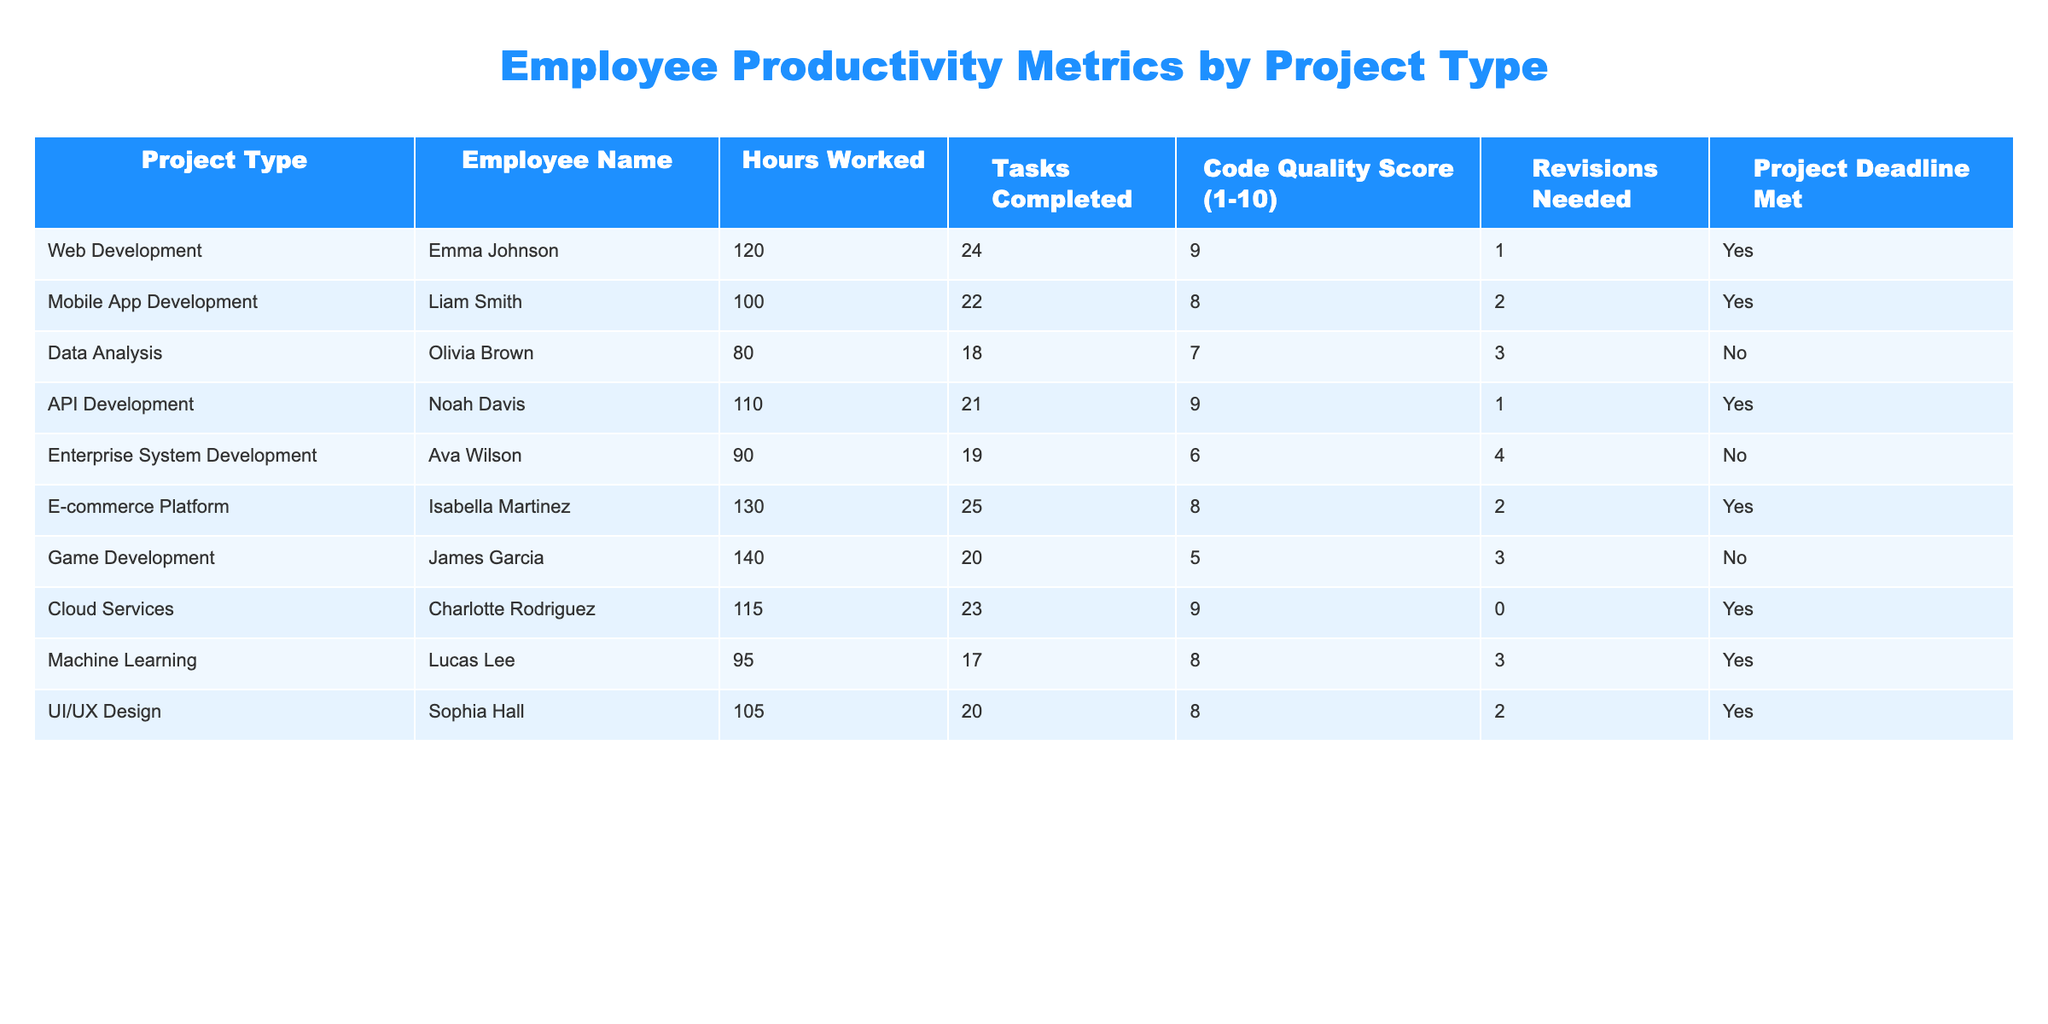What is the highest code quality score among the projects? By reviewing the "Code Quality Score" column, I identify the scores for each project type. The scores are: 9 (Web Development), 8 (Mobile App Development), 7 (Data Analysis), 9 (API Development), 6 (Enterprise System Development), 8 (E-commerce Platform), 5 (Game Development), 9 (Cloud Services), 8 (Machine Learning), and 8 (UI/UX Design). The highest score is 9.
Answer: 9 How many hours did employees work on Mobile App Development? Checking the "Hours Worked" column specifically for the row related to Mobile App Development, I find that Liam Smith worked 100 hours on that project.
Answer: 100 What percentage of projects met their deadlines? There are 10 total projects listed in the table. The "Project Deadline Met" column shows that 6 out of 10 projects were marked as "Yes" for meeting their deadlines. To find the percentage, I use the formula (Number of Projects that Met Deadline / Total Projects) * 100, which is (6/10) * 100 = 60%.
Answer: 60% Which project type had the lowest number of tasks completed? I analyze the "Tasks Completed" column to find the minimum value. The values are 24 (Web Development), 22 (Mobile App Development), 18 (Data Analysis), 21 (API Development), 19 (Enterprise System Development), 25 (E-commerce Platform), 20 (Game Development), 23 (Cloud Services), 17 (Machine Learning), and 20 (UI/UX Design). The lowest value is 17 tasks, associated with Machine Learning.
Answer: Machine Learning What is the average number of revisions needed across all projects? I examine the "Revisions Needed" column for each project: 1 (Web Development), 2 (Mobile App Development), 3 (Data Analysis), 1 (API Development), 4 (Enterprise System Development), 2 (E-commerce Platform), 3 (Game Development), 0 (Cloud Services), 3 (Machine Learning), and 2 (UI/UX Design). To find the average, I sum these values: 1 + 2 + 3 + 1 + 4 + 2 + 3 + 0 + 3 + 2 = 21. Then, I divide by the number of projects (10), resulting in an average of 21 / 10 = 2.1 revisions needed.
Answer: 2.1 Was there a project that had a high code quality score but did not meet its deadline? I check the "Code Quality Score" and "Project Deadline Met" columns simultaneously. Cloud Services and API Development scored 9 and met the deadline. However, Game Development had a code quality score of 5 and did not meet its deadline. Thus, no project with a high score of 9 failed to meet the deadline, but Game Development had a lower score and failed to meet it.
Answer: No What is the total number of tasks completed for Web Development and E-commerce Platform? I look at the "Tasks Completed" column for these two projects. Web Development had 24 tasks completed and E-commerce Platform had 25 tasks. By adding these together, I get a total of 24 + 25 = 49 tasks completed for these two projects.
Answer: 49 